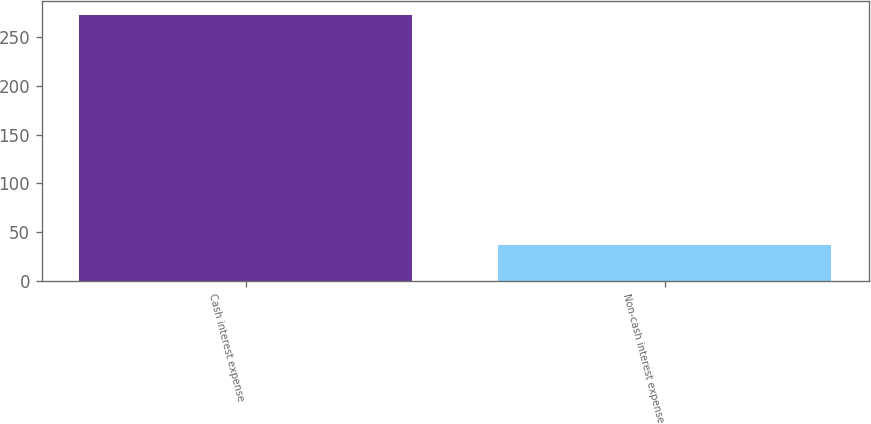<chart> <loc_0><loc_0><loc_500><loc_500><bar_chart><fcel>Cash interest expense<fcel>Non-cash interest expense<nl><fcel>273<fcel>37<nl></chart> 